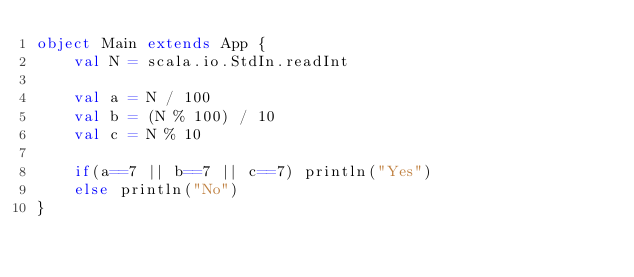<code> <loc_0><loc_0><loc_500><loc_500><_Scala_>object Main extends App {
	val N = scala.io.StdIn.readInt

	val a = N / 100
	val b = (N % 100) / 10
	val c = N % 10

	if(a==7 || b==7 || c==7) println("Yes")
	else println("No")
}</code> 